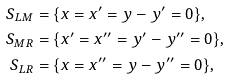Convert formula to latex. <formula><loc_0><loc_0><loc_500><loc_500>S _ { L M } & = \{ x = x ^ { \prime } = y - y ^ { \prime } = 0 \} , \\ S _ { M R } & = \{ x ^ { \prime } = x ^ { \prime \prime } = y ^ { \prime } - y ^ { \prime \prime } = 0 \} , \\ S _ { L R } & = \{ x = x ^ { \prime \prime } = y - y ^ { \prime \prime } = 0 \} ,</formula> 